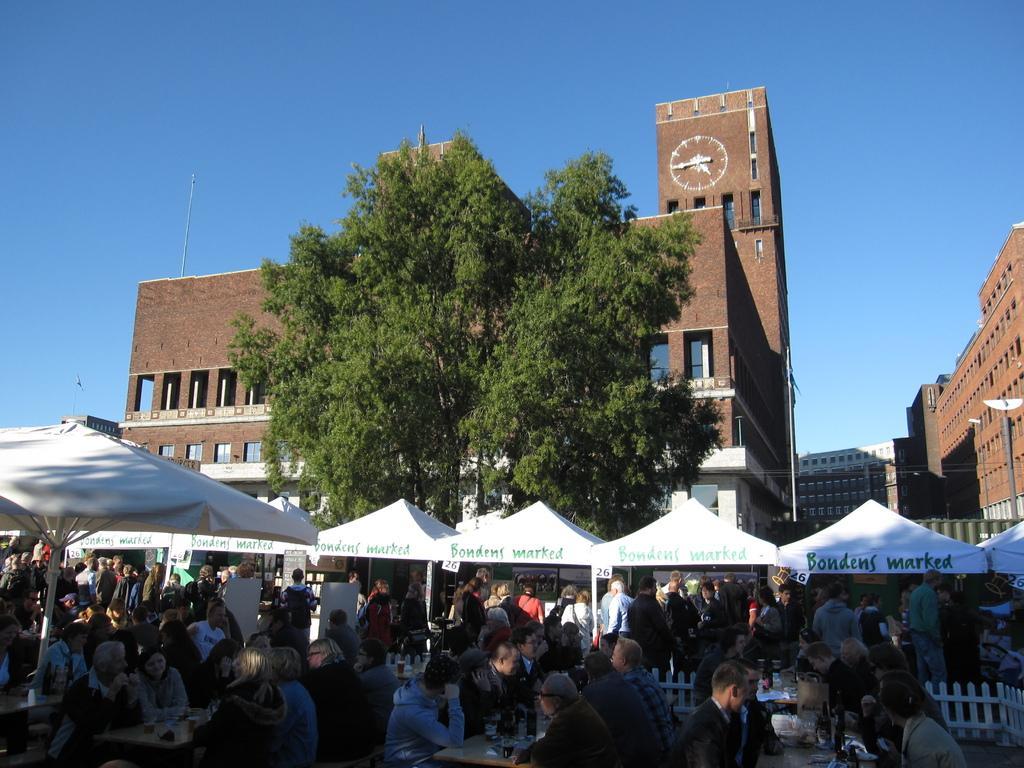In one or two sentences, can you explain what this image depicts? In this picture I can observe some people in the bottom of the picture. I can observe white color tents and a tree in the middle of the picture. In the background there are buildings and sky. 